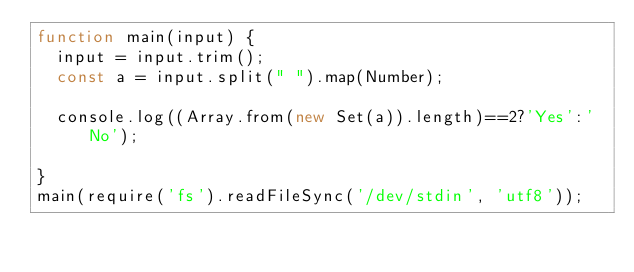Convert code to text. <code><loc_0><loc_0><loc_500><loc_500><_JavaScript_>function main(input) {
  input = input.trim();
  const a = input.split(" ").map(Number);
 
  console.log((Array.from(new Set(a)).length)==2?'Yes':'No');
 
}
main(require('fs').readFileSync('/dev/stdin', 'utf8'));</code> 